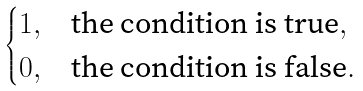Convert formula to latex. <formula><loc_0><loc_0><loc_500><loc_500>\begin{cases} 1 , & \text {the condition is true} , \\ 0 , & \text {the condition is false} . \end{cases}</formula> 